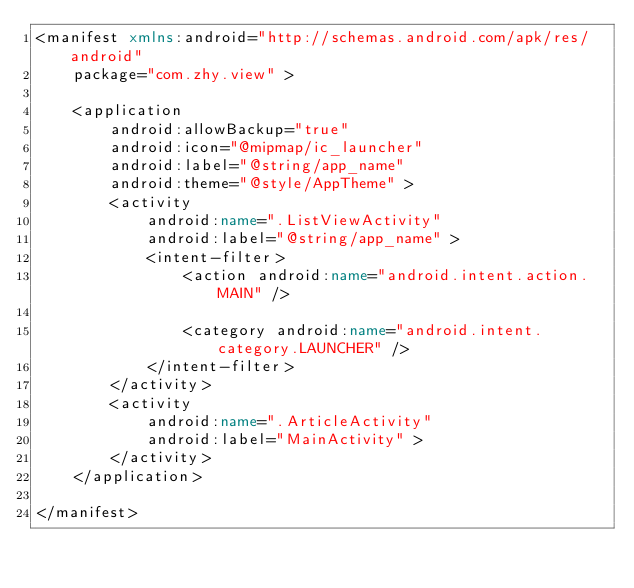<code> <loc_0><loc_0><loc_500><loc_500><_XML_><manifest xmlns:android="http://schemas.android.com/apk/res/android"
    package="com.zhy.view" >

    <application
        android:allowBackup="true"
        android:icon="@mipmap/ic_launcher"
        android:label="@string/app_name"
        android:theme="@style/AppTheme" >
        <activity
            android:name=".ListViewActivity"
            android:label="@string/app_name" >
            <intent-filter>
                <action android:name="android.intent.action.MAIN" />

                <category android:name="android.intent.category.LAUNCHER" />
            </intent-filter>
        </activity>
        <activity
            android:name=".ArticleActivity"
            android:label="MainActivity" >
        </activity>
    </application>

</manifest>
</code> 